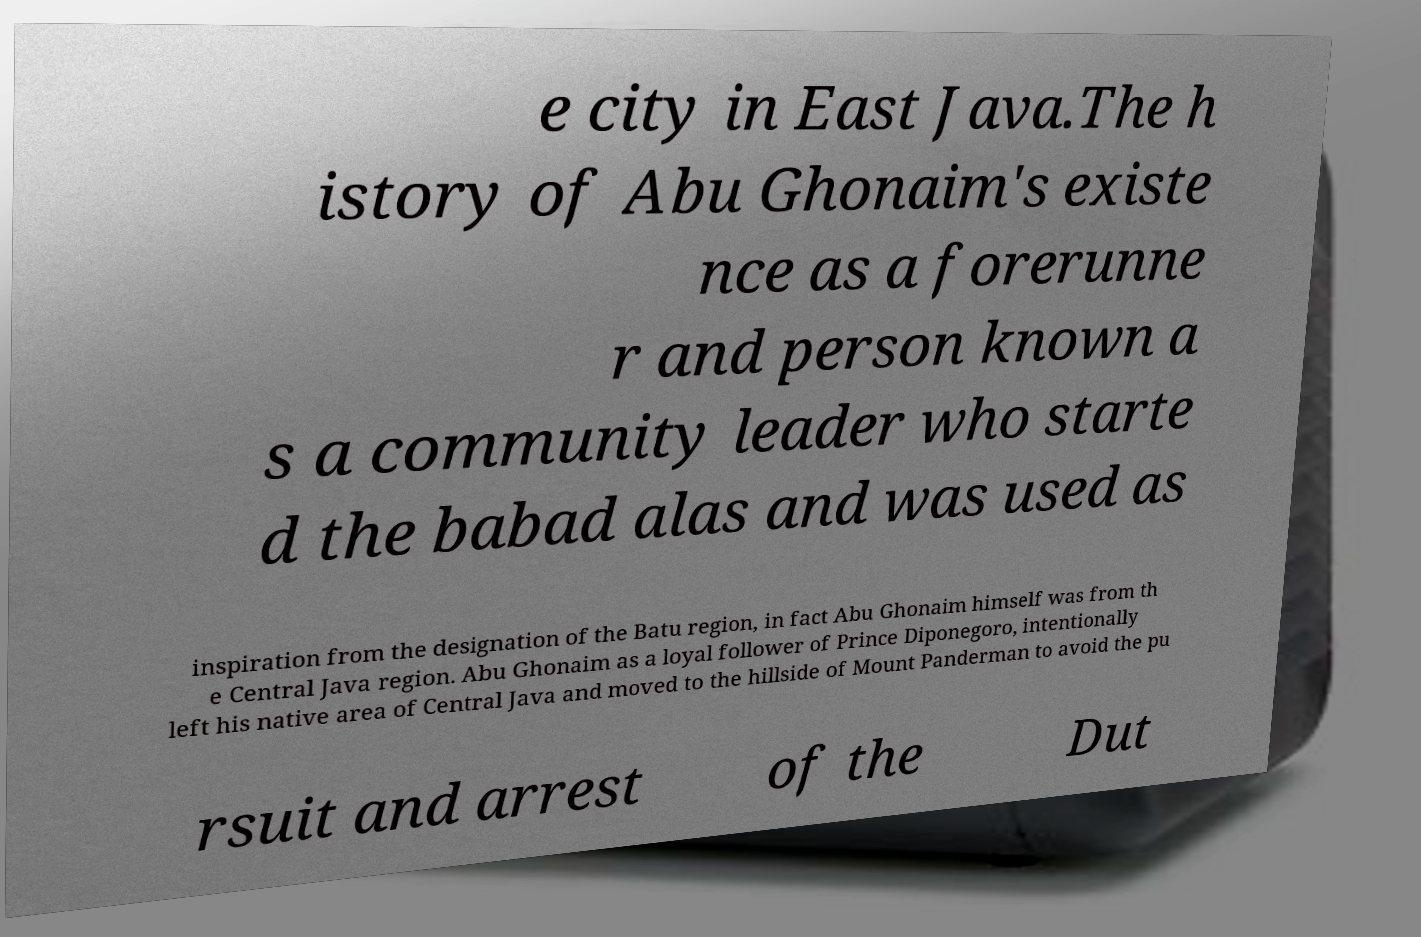I need the written content from this picture converted into text. Can you do that? e city in East Java.The h istory of Abu Ghonaim's existe nce as a forerunne r and person known a s a community leader who starte d the babad alas and was used as inspiration from the designation of the Batu region, in fact Abu Ghonaim himself was from th e Central Java region. Abu Ghonaim as a loyal follower of Prince Diponegoro, intentionally left his native area of Central Java and moved to the hillside of Mount Panderman to avoid the pu rsuit and arrest of the Dut 